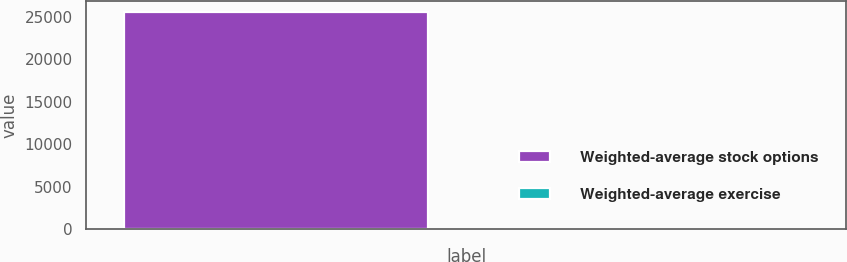Convert chart. <chart><loc_0><loc_0><loc_500><loc_500><bar_chart><fcel>Weighted-average stock options<fcel>Weighted-average exercise<nl><fcel>25632<fcel>36.46<nl></chart> 